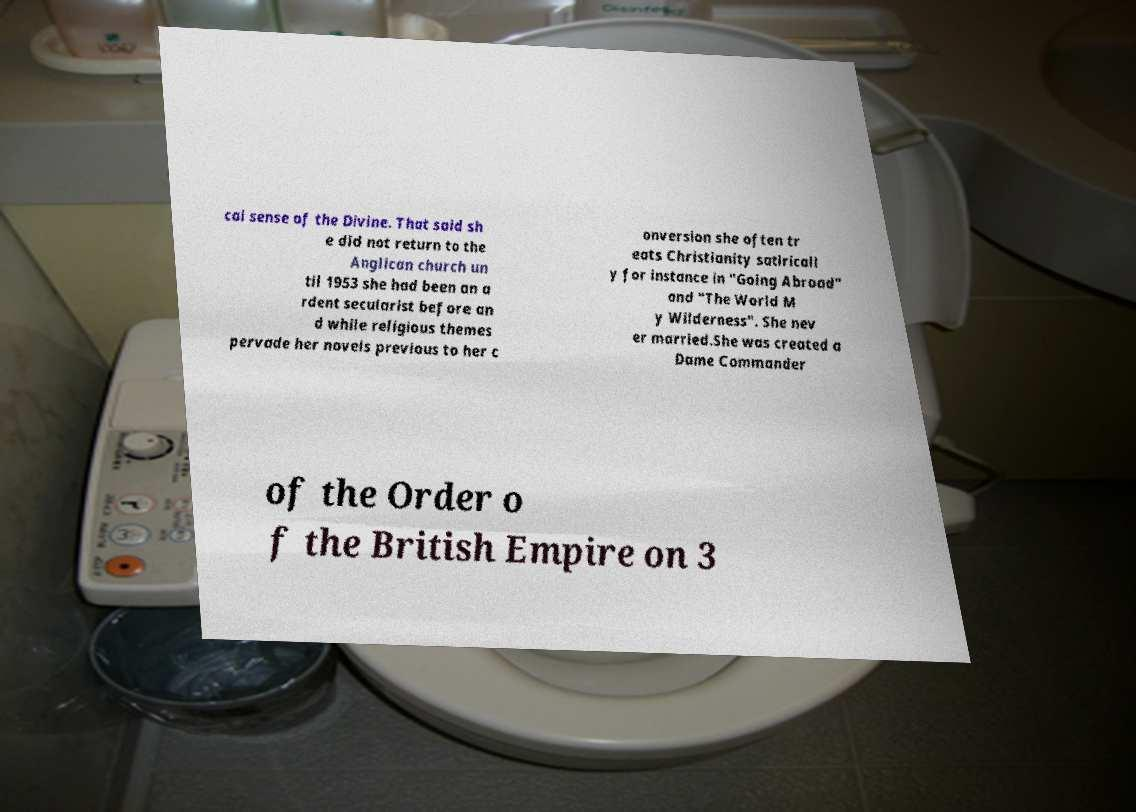For documentation purposes, I need the text within this image transcribed. Could you provide that? cal sense of the Divine. That said sh e did not return to the Anglican church un til 1953 she had been an a rdent secularist before an d while religious themes pervade her novels previous to her c onversion she often tr eats Christianity satiricall y for instance in "Going Abroad" and "The World M y Wilderness". She nev er married.She was created a Dame Commander of the Order o f the British Empire on 3 